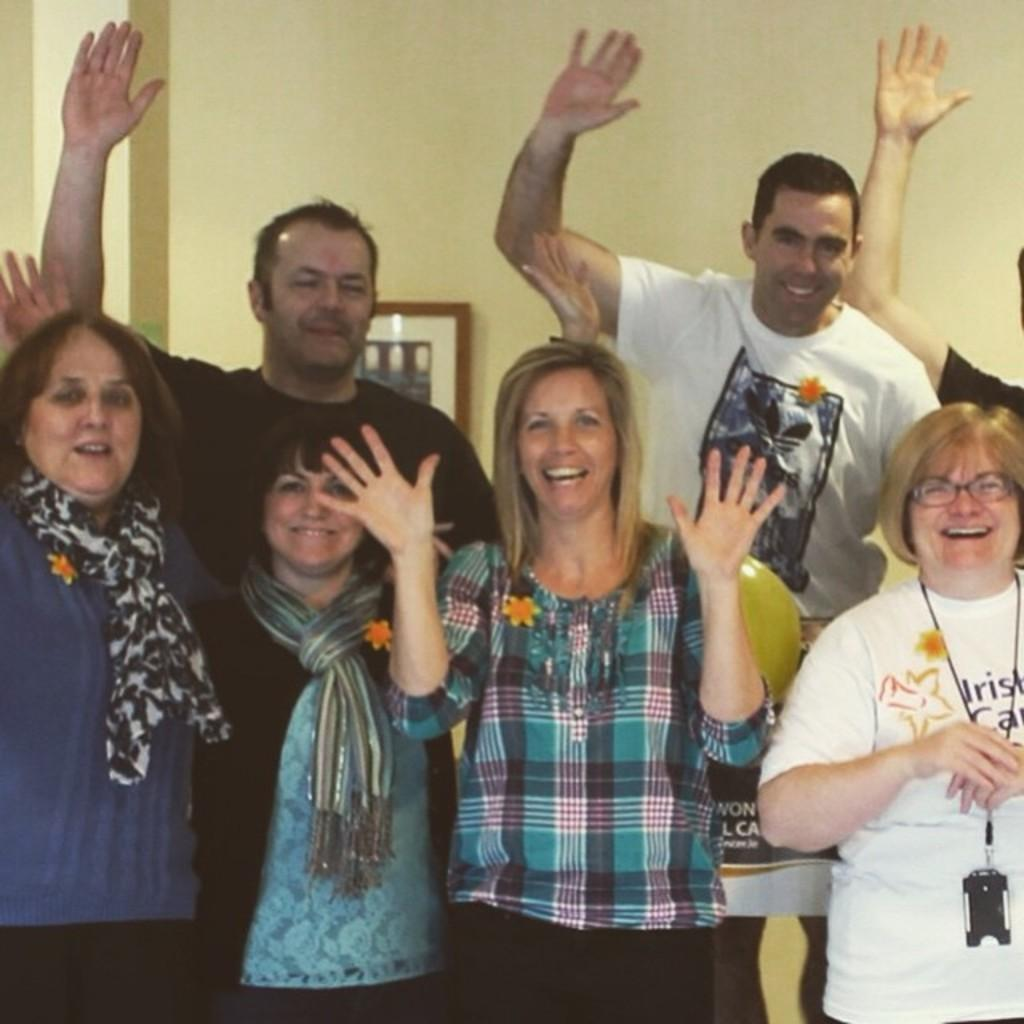How many people are present in the image? There are a few people in the image. What can be seen in the background of the image? There is a wall with a frame in the background of the image. Can you describe the yellow colored object in the image? Yes, there is a yellow colored object in the image. What type of grain is being harvested in the lunchroom in the image? There is no mention of grain or a lunchroom in the image, so this question cannot be answered. 